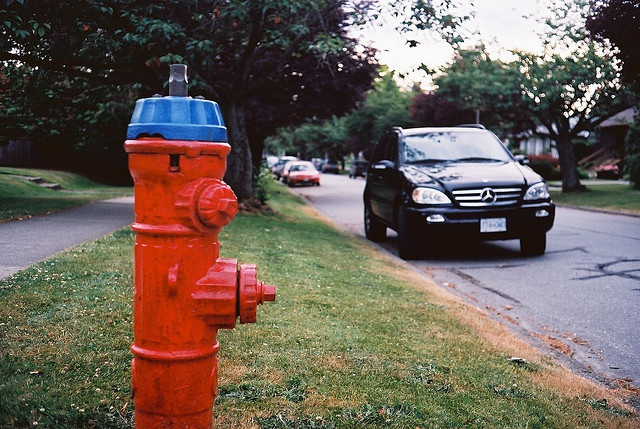Describe the objects in this image and their specific colors. I can see fire hydrant in black, brown, red, maroon, and salmon tones, car in black, lavender, gray, and darkgray tones, car in black, lavender, brown, and maroon tones, car in black, gray, and navy tones, and car in black and gray tones in this image. 